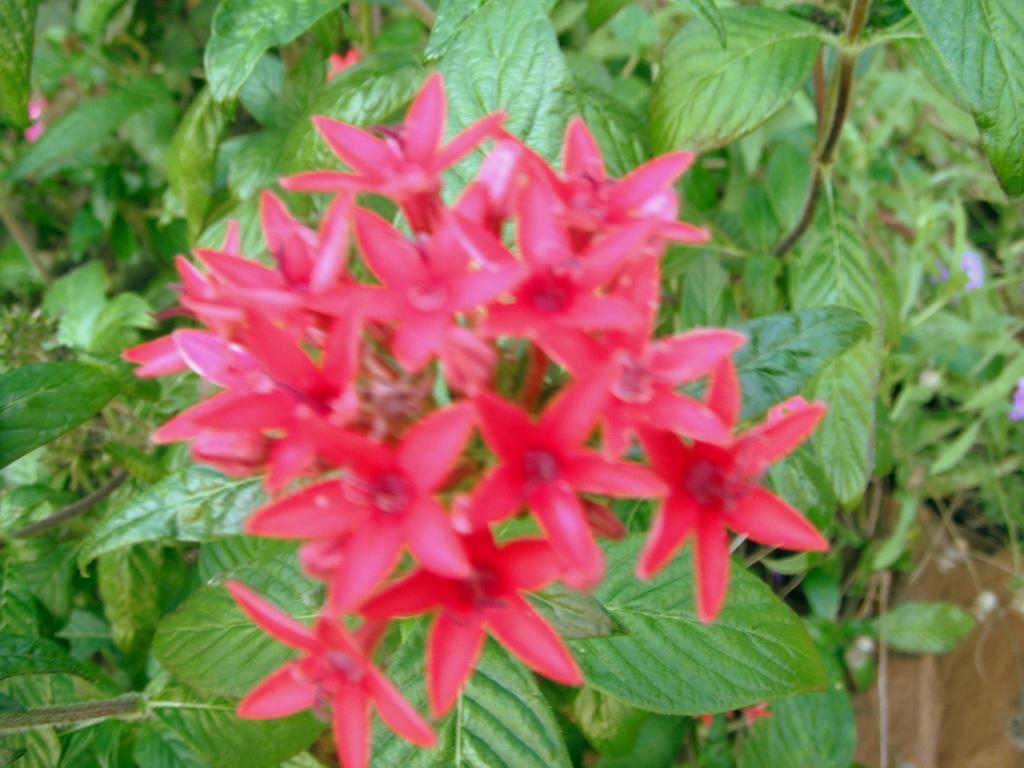In one or two sentences, can you explain what this image depicts? In this image we can see few flowers and trees in the background. 